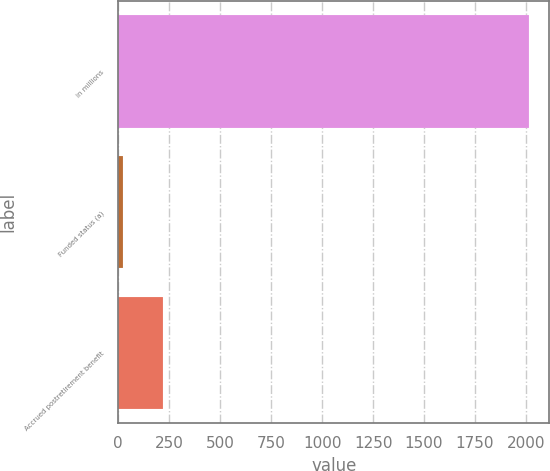<chart> <loc_0><loc_0><loc_500><loc_500><bar_chart><fcel>in millions<fcel>Funded status (a)<fcel>Accrued postretirement benefit<nl><fcel>2014<fcel>23<fcel>222.1<nl></chart> 